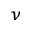Convert formula to latex. <formula><loc_0><loc_0><loc_500><loc_500>_ { \nu }</formula> 